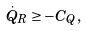<formula> <loc_0><loc_0><loc_500><loc_500>\dot { Q } _ { R } \geq - C _ { Q } ,</formula> 